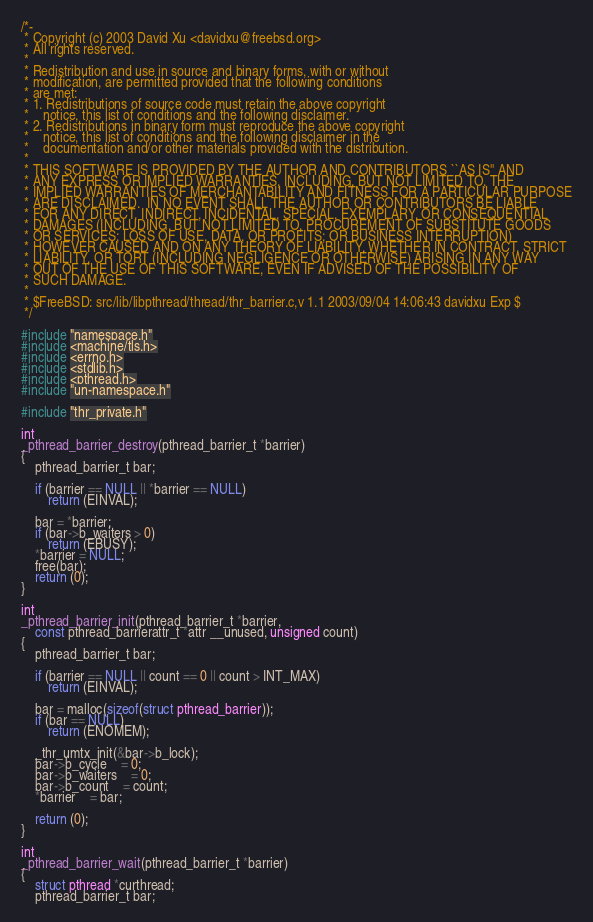Convert code to text. <code><loc_0><loc_0><loc_500><loc_500><_C_>/*-
 * Copyright (c) 2003 David Xu <davidxu@freebsd.org>
 * All rights reserved.
 *
 * Redistribution and use in source and binary forms, with or without
 * modification, are permitted provided that the following conditions
 * are met:
 * 1. Redistributions of source code must retain the above copyright
 *    notice, this list of conditions and the following disclaimer.
 * 2. Redistributions in binary form must reproduce the above copyright
 *    notice, this list of conditions and the following disclaimer in the
 *    documentation and/or other materials provided with the distribution.
 *
 * THIS SOFTWARE IS PROVIDED BY THE AUTHOR AND CONTRIBUTORS ``AS IS'' AND
 * ANY EXPRESS OR IMPLIED WARRANTIES, INCLUDING, BUT NOT LIMITED TO, THE
 * IMPLIED WARRANTIES OF MERCHANTABILITY AND FITNESS FOR A PARTICULAR PURPOSE
 * ARE DISCLAIMED.  IN NO EVENT SHALL THE AUTHOR OR CONTRIBUTORS BE LIABLE
 * FOR ANY DIRECT, INDIRECT, INCIDENTAL, SPECIAL, EXEMPLARY, OR CONSEQUENTIAL
 * DAMAGES (INCLUDING, BUT NOT LIMITED TO, PROCUREMENT OF SUBSTITUTE GOODS
 * OR SERVICES; LOSS OF USE, DATA, OR PROFITS; OR BUSINESS INTERRUPTION)
 * HOWEVER CAUSED AND ON ANY THEORY OF LIABILITY, WHETHER IN CONTRACT, STRICT
 * LIABILITY, OR TORT (INCLUDING NEGLIGENCE OR OTHERWISE) ARISING IN ANY WAY
 * OUT OF THE USE OF THIS SOFTWARE, EVEN IF ADVISED OF THE POSSIBILITY OF
 * SUCH DAMAGE.
 *
 * $FreeBSD: src/lib/libpthread/thread/thr_barrier.c,v 1.1 2003/09/04 14:06:43 davidxu Exp $
 */

#include "namespace.h"
#include <machine/tls.h>
#include <errno.h>
#include <stdlib.h>
#include <pthread.h>
#include "un-namespace.h"

#include "thr_private.h"

int
_pthread_barrier_destroy(pthread_barrier_t *barrier)
{
	pthread_barrier_t bar;

	if (barrier == NULL || *barrier == NULL)
		return (EINVAL);

	bar = *barrier;
	if (bar->b_waiters > 0)
		return (EBUSY);
	*barrier = NULL;
	free(bar);
	return (0);
}

int
_pthread_barrier_init(pthread_barrier_t *barrier,
    const pthread_barrierattr_t *attr __unused, unsigned count)
{
	pthread_barrier_t bar;

	if (barrier == NULL || count == 0 || count > INT_MAX)
		return (EINVAL);

	bar = malloc(sizeof(struct pthread_barrier));
	if (bar == NULL)
		return (ENOMEM);

	_thr_umtx_init(&bar->b_lock);
	bar->b_cycle	= 0;
	bar->b_waiters	= 0;
	bar->b_count	= count;
	*barrier	= bar;

	return (0);
}

int
_pthread_barrier_wait(pthread_barrier_t *barrier)
{
	struct pthread *curthread;
	pthread_barrier_t bar;</code> 